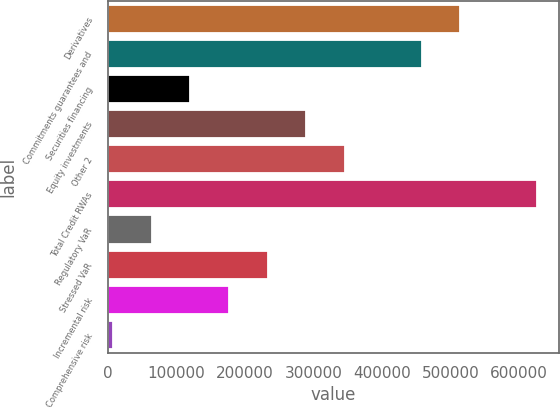<chart> <loc_0><loc_0><loc_500><loc_500><bar_chart><fcel>Derivatives<fcel>Commitments guarantees and<fcel>Securities financing<fcel>Equity investments<fcel>Other 2<fcel>Total Credit RWAs<fcel>Regulatory VaR<fcel>Stressed VaR<fcel>Incremental risk<fcel>Comprehensive risk<nl><fcel>514097<fcel>457880<fcel>120583<fcel>289232<fcel>345448<fcel>626529<fcel>64366.3<fcel>233015<fcel>176799<fcel>8150<nl></chart> 